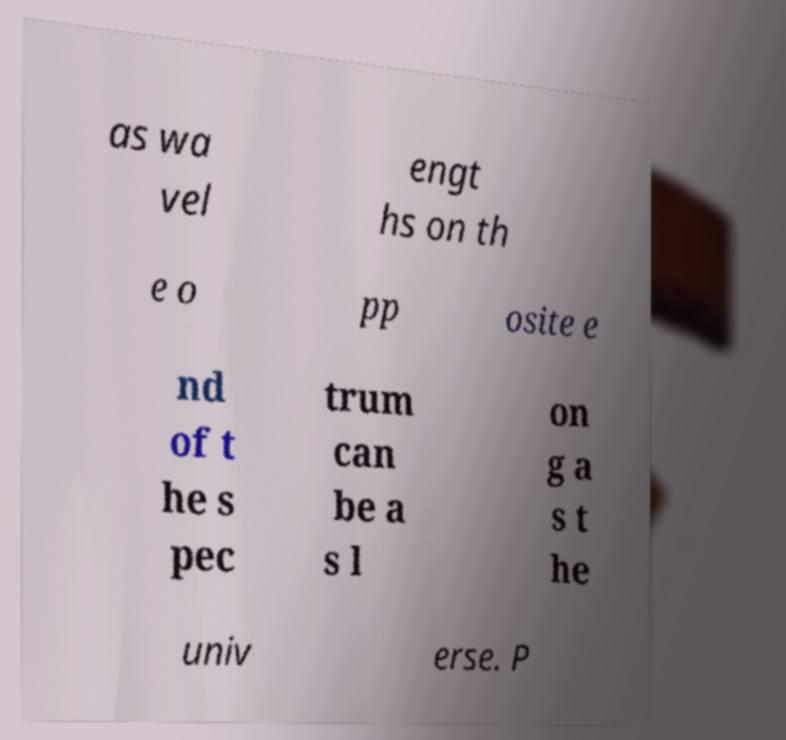For documentation purposes, I need the text within this image transcribed. Could you provide that? as wa vel engt hs on th e o pp osite e nd of t he s pec trum can be a s l on g a s t he univ erse. P 